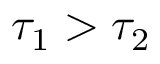Convert formula to latex. <formula><loc_0><loc_0><loc_500><loc_500>\tau _ { 1 } > \tau _ { 2 }</formula> 